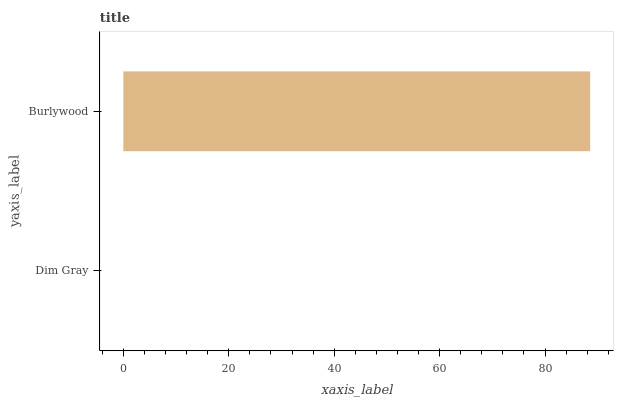Is Dim Gray the minimum?
Answer yes or no. Yes. Is Burlywood the maximum?
Answer yes or no. Yes. Is Burlywood the minimum?
Answer yes or no. No. Is Burlywood greater than Dim Gray?
Answer yes or no. Yes. Is Dim Gray less than Burlywood?
Answer yes or no. Yes. Is Dim Gray greater than Burlywood?
Answer yes or no. No. Is Burlywood less than Dim Gray?
Answer yes or no. No. Is Burlywood the high median?
Answer yes or no. Yes. Is Dim Gray the low median?
Answer yes or no. Yes. Is Dim Gray the high median?
Answer yes or no. No. Is Burlywood the low median?
Answer yes or no. No. 